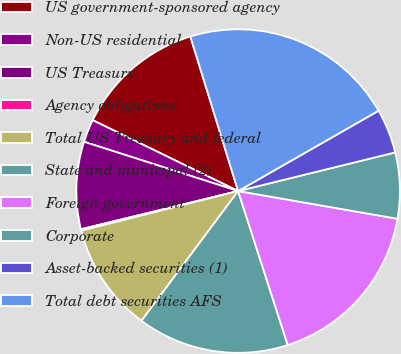Convert chart to OTSL. <chart><loc_0><loc_0><loc_500><loc_500><pie_chart><fcel>US government-sponsored agency<fcel>Non-US residential<fcel>US Treasury<fcel>Agency obligations<fcel>Total US Treasury and federal<fcel>State and municipal (2)<fcel>Foreign government<fcel>Corporate<fcel>Asset-backed securities (1)<fcel>Total debt securities AFS<nl><fcel>13.01%<fcel>2.29%<fcel>8.72%<fcel>0.15%<fcel>10.87%<fcel>15.15%<fcel>17.3%<fcel>6.58%<fcel>4.43%<fcel>21.5%<nl></chart> 